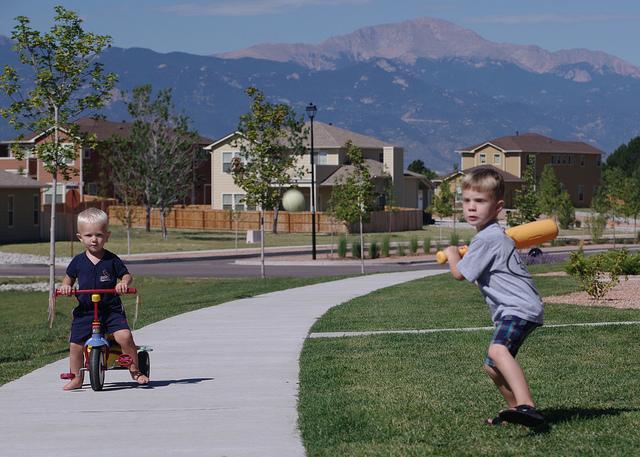How many kids are in the picture?
Give a very brief answer. 2. How many people are there?
Give a very brief answer. 2. How many birds are in the photo?
Give a very brief answer. 0. 